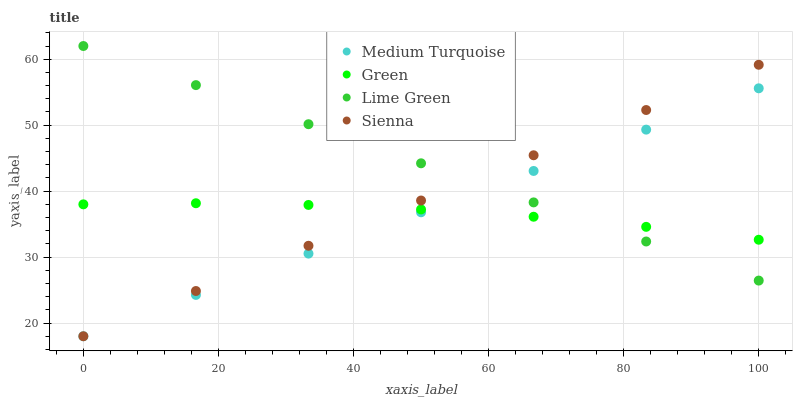Does Green have the minimum area under the curve?
Answer yes or no. Yes. Does Lime Green have the maximum area under the curve?
Answer yes or no. Yes. Does Lime Green have the minimum area under the curve?
Answer yes or no. No. Does Green have the maximum area under the curve?
Answer yes or no. No. Is Lime Green the smoothest?
Answer yes or no. Yes. Is Green the roughest?
Answer yes or no. Yes. Is Green the smoothest?
Answer yes or no. No. Is Lime Green the roughest?
Answer yes or no. No. Does Sienna have the lowest value?
Answer yes or no. Yes. Does Lime Green have the lowest value?
Answer yes or no. No. Does Lime Green have the highest value?
Answer yes or no. Yes. Does Green have the highest value?
Answer yes or no. No. Does Sienna intersect Green?
Answer yes or no. Yes. Is Sienna less than Green?
Answer yes or no. No. Is Sienna greater than Green?
Answer yes or no. No. 